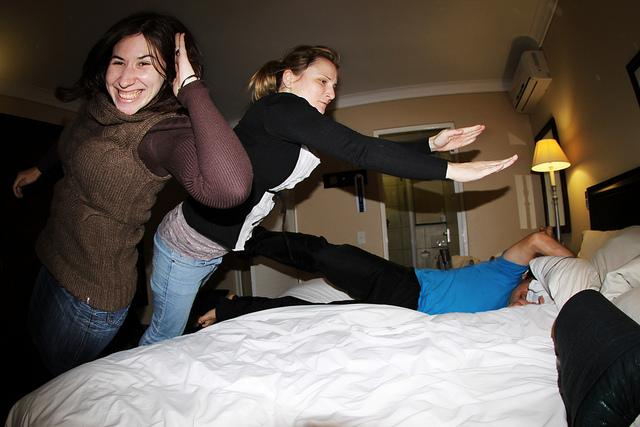It is time to hit the?

Choices:
A) bed
B) waves
C) hay
D) weights hay 